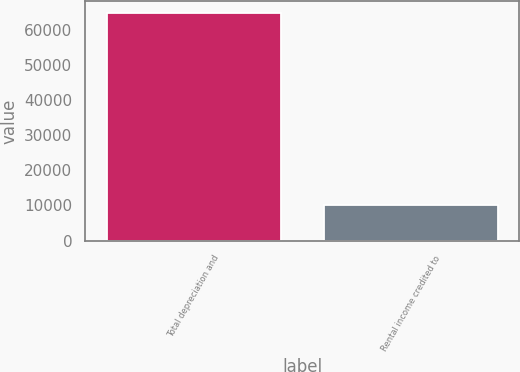Convert chart. <chart><loc_0><loc_0><loc_500><loc_500><bar_chart><fcel>Total depreciation and<fcel>Rental income credited to<nl><fcel>64934<fcel>10108<nl></chart> 